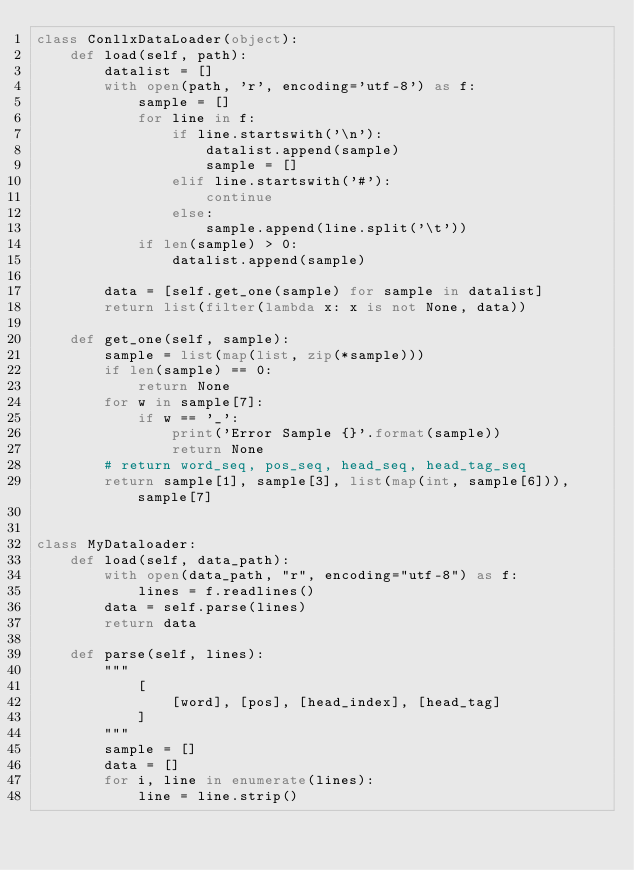<code> <loc_0><loc_0><loc_500><loc_500><_Python_>class ConllxDataLoader(object):
    def load(self, path):
        datalist = []
        with open(path, 'r', encoding='utf-8') as f:
            sample = []
            for line in f:
                if line.startswith('\n'):
                    datalist.append(sample)
                    sample = []
                elif line.startswith('#'):
                    continue
                else:
                    sample.append(line.split('\t'))
            if len(sample) > 0:
                datalist.append(sample)

        data = [self.get_one(sample) for sample in datalist]
        return list(filter(lambda x: x is not None, data))

    def get_one(self, sample):
        sample = list(map(list, zip(*sample)))
        if len(sample) == 0:
            return None
        for w in sample[7]:
            if w == '_':
                print('Error Sample {}'.format(sample))
                return None
        # return word_seq, pos_seq, head_seq, head_tag_seq
        return sample[1], sample[3], list(map(int, sample[6])), sample[7]


class MyDataloader:
    def load(self, data_path):
        with open(data_path, "r", encoding="utf-8") as f:
            lines = f.readlines()
        data = self.parse(lines)
        return data

    def parse(self, lines):
        """
            [
                [word], [pos], [head_index], [head_tag]
            ]
        """
        sample = []
        data = []
        for i, line in enumerate(lines):
            line = line.strip()</code> 